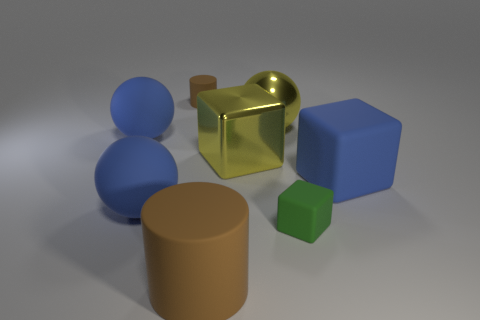Subtract all matte spheres. How many spheres are left? 1 Subtract all yellow spheres. How many spheres are left? 2 Subtract 1 cylinders. How many cylinders are left? 1 Add 1 blue matte spheres. How many objects exist? 9 Subtract all balls. How many objects are left? 5 Subtract all large blue matte cubes. Subtract all small brown objects. How many objects are left? 6 Add 4 small rubber cylinders. How many small rubber cylinders are left? 5 Add 7 big yellow balls. How many big yellow balls exist? 8 Subtract 0 red balls. How many objects are left? 8 Subtract all yellow blocks. Subtract all red balls. How many blocks are left? 2 